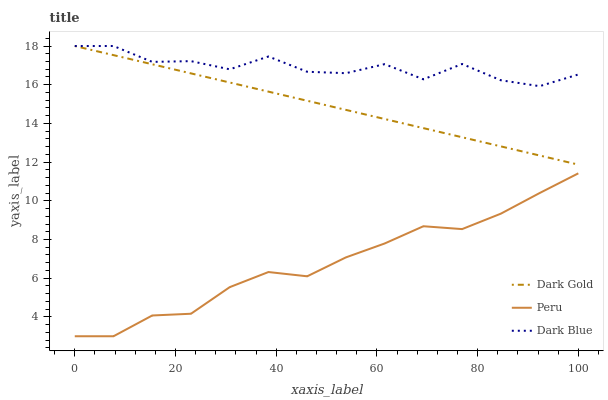Does Peru have the minimum area under the curve?
Answer yes or no. Yes. Does Dark Blue have the maximum area under the curve?
Answer yes or no. Yes. Does Dark Gold have the minimum area under the curve?
Answer yes or no. No. Does Dark Gold have the maximum area under the curve?
Answer yes or no. No. Is Dark Gold the smoothest?
Answer yes or no. Yes. Is Dark Blue the roughest?
Answer yes or no. Yes. Is Peru the smoothest?
Answer yes or no. No. Is Peru the roughest?
Answer yes or no. No. Does Dark Gold have the lowest value?
Answer yes or no. No. Does Dark Gold have the highest value?
Answer yes or no. Yes. Does Peru have the highest value?
Answer yes or no. No. Is Peru less than Dark Gold?
Answer yes or no. Yes. Is Dark Gold greater than Peru?
Answer yes or no. Yes. Does Dark Blue intersect Dark Gold?
Answer yes or no. Yes. Is Dark Blue less than Dark Gold?
Answer yes or no. No. Is Dark Blue greater than Dark Gold?
Answer yes or no. No. Does Peru intersect Dark Gold?
Answer yes or no. No. 